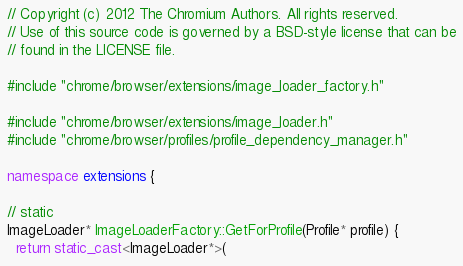<code> <loc_0><loc_0><loc_500><loc_500><_C++_>// Copyright (c) 2012 The Chromium Authors. All rights reserved.
// Use of this source code is governed by a BSD-style license that can be
// found in the LICENSE file.

#include "chrome/browser/extensions/image_loader_factory.h"

#include "chrome/browser/extensions/image_loader.h"
#include "chrome/browser/profiles/profile_dependency_manager.h"

namespace extensions {

// static
ImageLoader* ImageLoaderFactory::GetForProfile(Profile* profile) {
  return static_cast<ImageLoader*>(</code> 